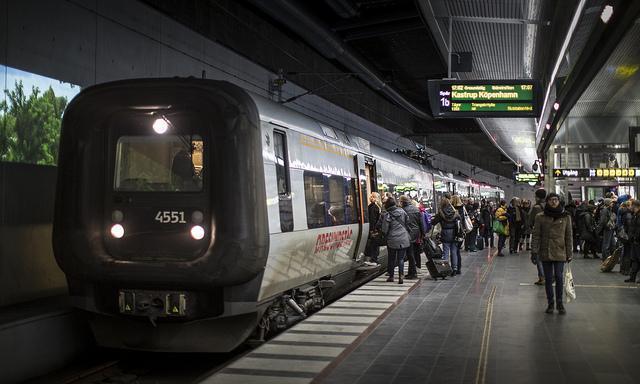What can be seen to the left of the train?
Make your selection from the four choices given to correctly answer the question.
Options: Ocean, roads, trees, mountains. Trees. 